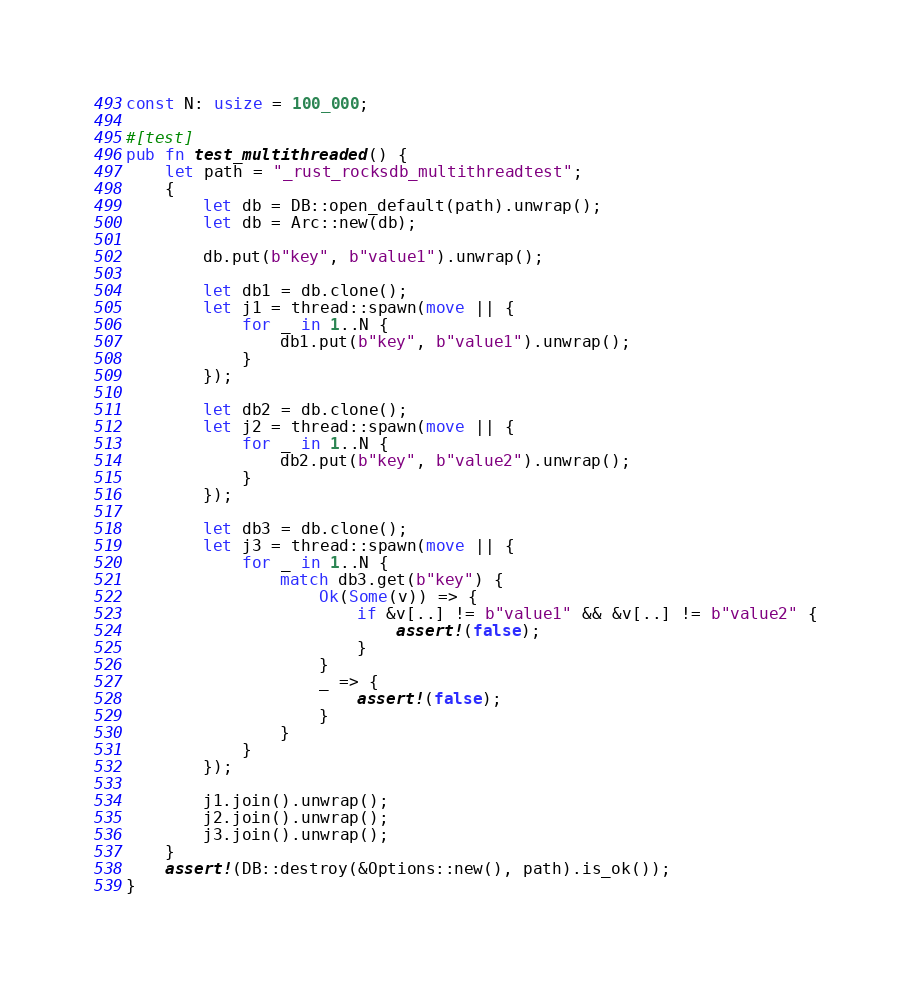<code> <loc_0><loc_0><loc_500><loc_500><_Rust_>
const N: usize = 100_000;

#[test]
pub fn test_multithreaded() {
    let path = "_rust_rocksdb_multithreadtest";
    {
        let db = DB::open_default(path).unwrap();
        let db = Arc::new(db);

        db.put(b"key", b"value1").unwrap();

        let db1 = db.clone();
        let j1 = thread::spawn(move || {
            for _ in 1..N {
                db1.put(b"key", b"value1").unwrap();
            }
        });

        let db2 = db.clone();
        let j2 = thread::spawn(move || {
            for _ in 1..N {
                db2.put(b"key", b"value2").unwrap();
            }
        });

        let db3 = db.clone();
        let j3 = thread::spawn(move || {
            for _ in 1..N {
                match db3.get(b"key") {
                    Ok(Some(v)) => {
                        if &v[..] != b"value1" && &v[..] != b"value2" {
                            assert!(false);
                        }
                    }
                    _ => {
                        assert!(false);
                    }
                }
            }
        });

        j1.join().unwrap();
        j2.join().unwrap();
        j3.join().unwrap();
    }
    assert!(DB::destroy(&Options::new(), path).is_ok());
}
</code> 